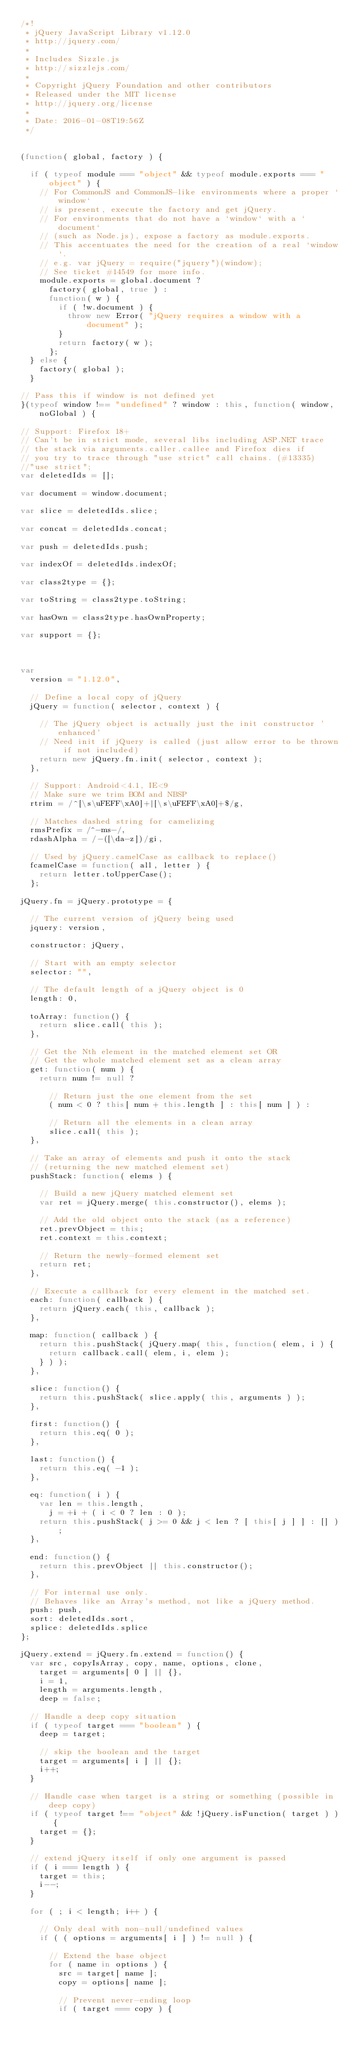Convert code to text. <code><loc_0><loc_0><loc_500><loc_500><_JavaScript_>/*!
 * jQuery JavaScript Library v1.12.0
 * http://jquery.com/
 *
 * Includes Sizzle.js
 * http://sizzlejs.com/
 *
 * Copyright jQuery Foundation and other contributors
 * Released under the MIT license
 * http://jquery.org/license
 *
 * Date: 2016-01-08T19:56Z
 */


(function( global, factory ) {

	if ( typeof module === "object" && typeof module.exports === "object" ) {
		// For CommonJS and CommonJS-like environments where a proper `window`
		// is present, execute the factory and get jQuery.
		// For environments that do not have a `window` with a `document`
		// (such as Node.js), expose a factory as module.exports.
		// This accentuates the need for the creation of a real `window`.
		// e.g. var jQuery = require("jquery")(window);
		// See ticket #14549 for more info.
		module.exports = global.document ?
			factory( global, true ) :
			function( w ) {
				if ( !w.document ) {
					throw new Error( "jQuery requires a window with a document" );
				}
				return factory( w );
			};
	} else {
		factory( global );
	}

// Pass this if window is not defined yet
}(typeof window !== "undefined" ? window : this, function( window, noGlobal ) {

// Support: Firefox 18+
// Can't be in strict mode, several libs including ASP.NET trace
// the stack via arguments.caller.callee and Firefox dies if
// you try to trace through "use strict" call chains. (#13335)
//"use strict";
var deletedIds = [];

var document = window.document;

var slice = deletedIds.slice;

var concat = deletedIds.concat;

var push = deletedIds.push;

var indexOf = deletedIds.indexOf;

var class2type = {};

var toString = class2type.toString;

var hasOwn = class2type.hasOwnProperty;

var support = {};



var
	version = "1.12.0",

	// Define a local copy of jQuery
	jQuery = function( selector, context ) {

		// The jQuery object is actually just the init constructor 'enhanced'
		// Need init if jQuery is called (just allow error to be thrown if not included)
		return new jQuery.fn.init( selector, context );
	},

	// Support: Android<4.1, IE<9
	// Make sure we trim BOM and NBSP
	rtrim = /^[\s\uFEFF\xA0]+|[\s\uFEFF\xA0]+$/g,

	// Matches dashed string for camelizing
	rmsPrefix = /^-ms-/,
	rdashAlpha = /-([\da-z])/gi,

	// Used by jQuery.camelCase as callback to replace()
	fcamelCase = function( all, letter ) {
		return letter.toUpperCase();
	};

jQuery.fn = jQuery.prototype = {

	// The current version of jQuery being used
	jquery: version,

	constructor: jQuery,

	// Start with an empty selector
	selector: "",

	// The default length of a jQuery object is 0
	length: 0,

	toArray: function() {
		return slice.call( this );
	},

	// Get the Nth element in the matched element set OR
	// Get the whole matched element set as a clean array
	get: function( num ) {
		return num != null ?

			// Return just the one element from the set
			( num < 0 ? this[ num + this.length ] : this[ num ] ) :

			// Return all the elements in a clean array
			slice.call( this );
	},

	// Take an array of elements and push it onto the stack
	// (returning the new matched element set)
	pushStack: function( elems ) {

		// Build a new jQuery matched element set
		var ret = jQuery.merge( this.constructor(), elems );

		// Add the old object onto the stack (as a reference)
		ret.prevObject = this;
		ret.context = this.context;

		// Return the newly-formed element set
		return ret;
	},

	// Execute a callback for every element in the matched set.
	each: function( callback ) {
		return jQuery.each( this, callback );
	},

	map: function( callback ) {
		return this.pushStack( jQuery.map( this, function( elem, i ) {
			return callback.call( elem, i, elem );
		} ) );
	},

	slice: function() {
		return this.pushStack( slice.apply( this, arguments ) );
	},

	first: function() {
		return this.eq( 0 );
	},

	last: function() {
		return this.eq( -1 );
	},

	eq: function( i ) {
		var len = this.length,
			j = +i + ( i < 0 ? len : 0 );
		return this.pushStack( j >= 0 && j < len ? [ this[ j ] ] : [] );
	},

	end: function() {
		return this.prevObject || this.constructor();
	},

	// For internal use only.
	// Behaves like an Array's method, not like a jQuery method.
	push: push,
	sort: deletedIds.sort,
	splice: deletedIds.splice
};

jQuery.extend = jQuery.fn.extend = function() {
	var src, copyIsArray, copy, name, options, clone,
		target = arguments[ 0 ] || {},
		i = 1,
		length = arguments.length,
		deep = false;

	// Handle a deep copy situation
	if ( typeof target === "boolean" ) {
		deep = target;

		// skip the boolean and the target
		target = arguments[ i ] || {};
		i++;
	}

	// Handle case when target is a string or something (possible in deep copy)
	if ( typeof target !== "object" && !jQuery.isFunction( target ) ) {
		target = {};
	}

	// extend jQuery itself if only one argument is passed
	if ( i === length ) {
		target = this;
		i--;
	}

	for ( ; i < length; i++ ) {

		// Only deal with non-null/undefined values
		if ( ( options = arguments[ i ] ) != null ) {

			// Extend the base object
			for ( name in options ) {
				src = target[ name ];
				copy = options[ name ];

				// Prevent never-ending loop
				if ( target === copy ) {</code> 